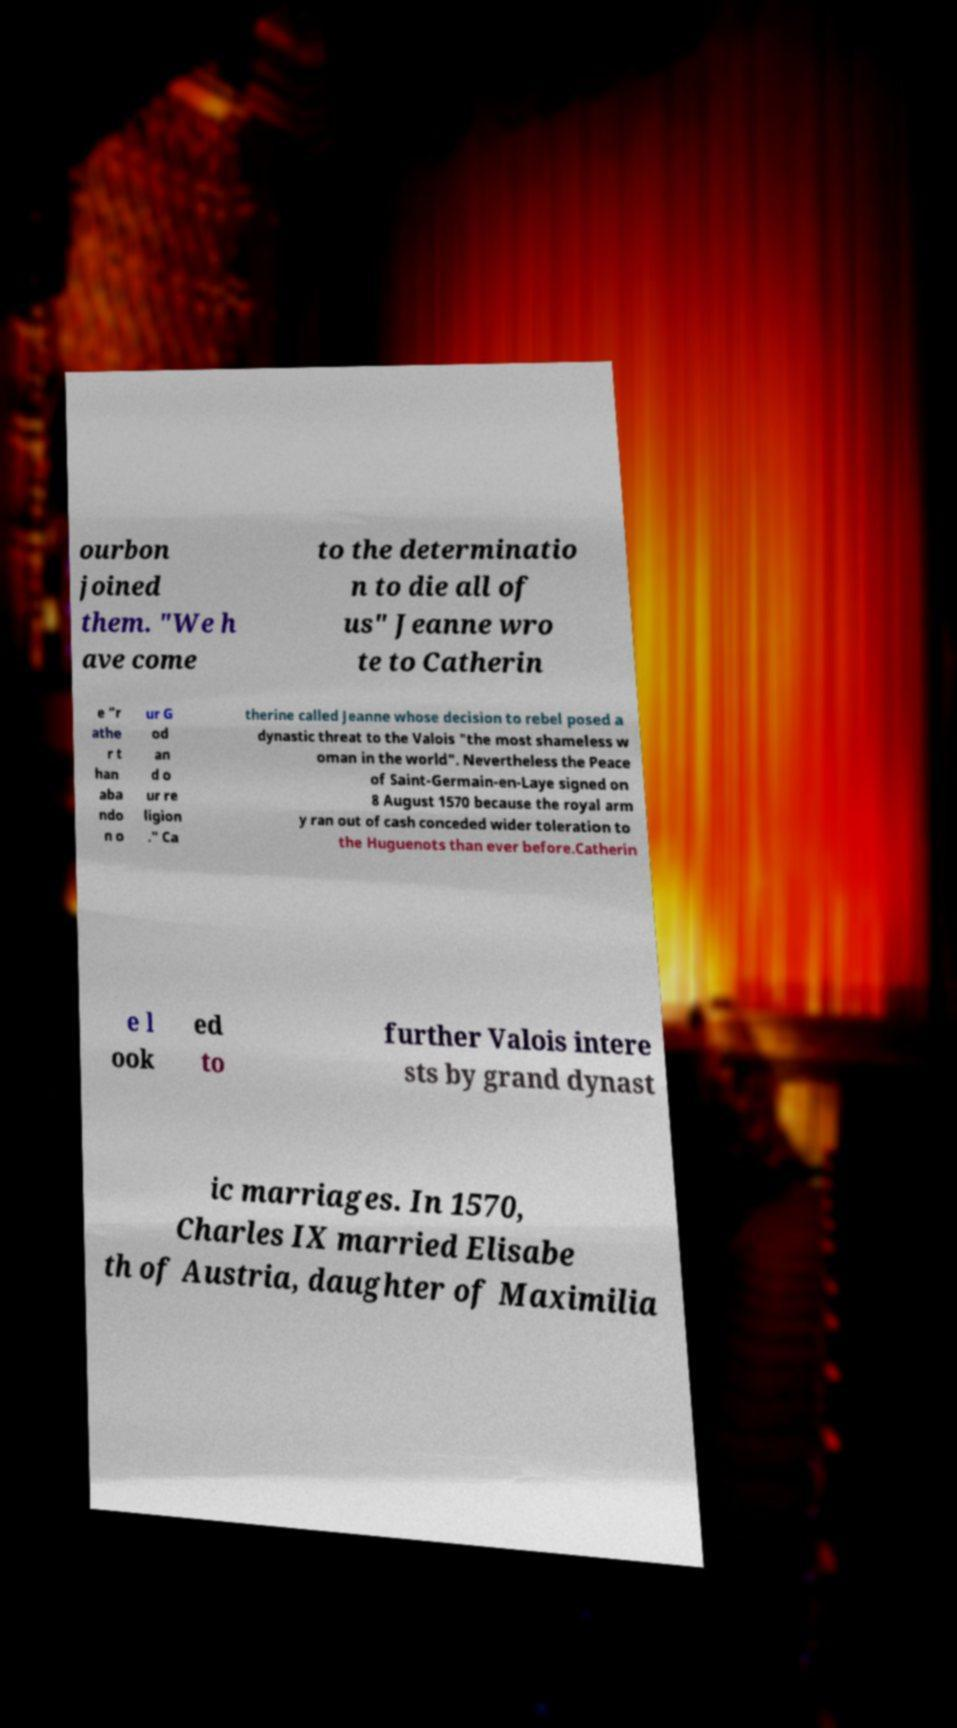Could you extract and type out the text from this image? ourbon joined them. "We h ave come to the determinatio n to die all of us" Jeanne wro te to Catherin e "r athe r t han aba ndo n o ur G od an d o ur re ligion ." Ca therine called Jeanne whose decision to rebel posed a dynastic threat to the Valois "the most shameless w oman in the world". Nevertheless the Peace of Saint-Germain-en-Laye signed on 8 August 1570 because the royal arm y ran out of cash conceded wider toleration to the Huguenots than ever before.Catherin e l ook ed to further Valois intere sts by grand dynast ic marriages. In 1570, Charles IX married Elisabe th of Austria, daughter of Maximilia 